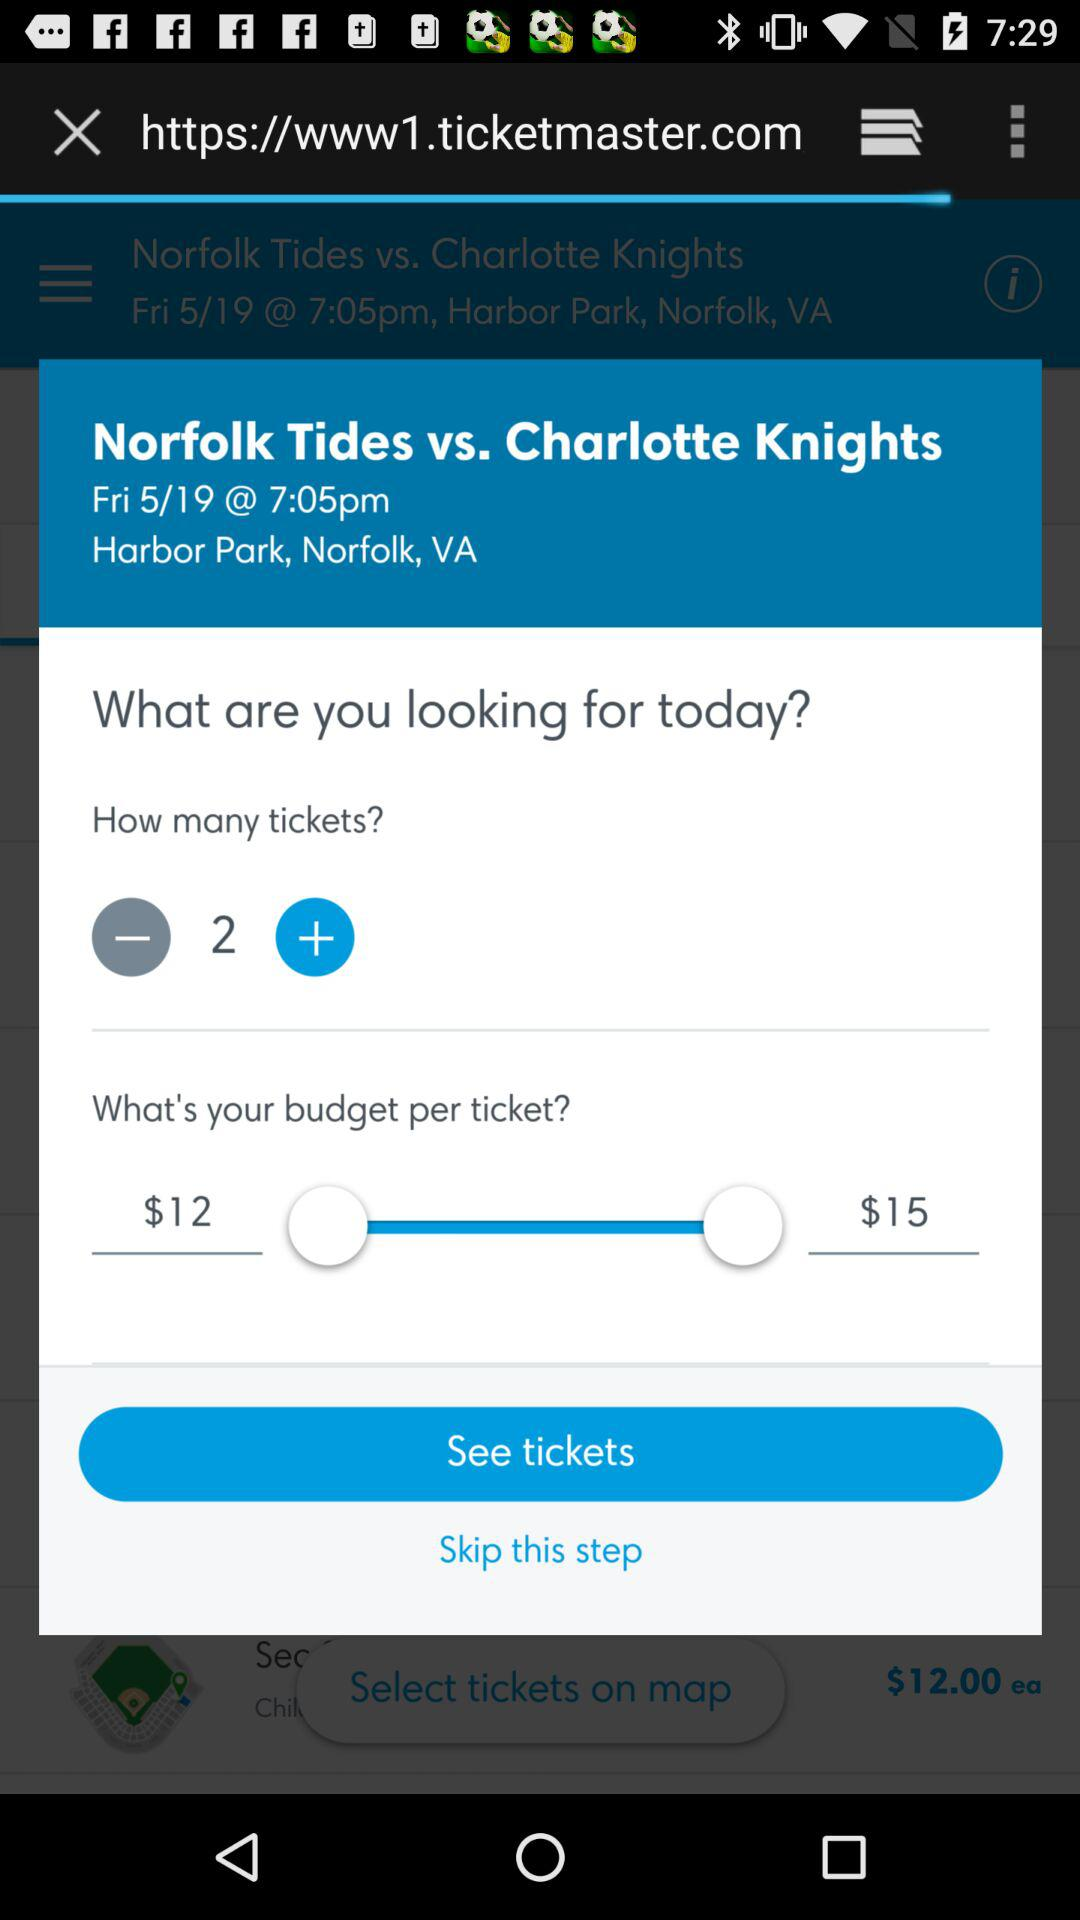What date is scheduled? The scheduled date is Friday, May 19. 